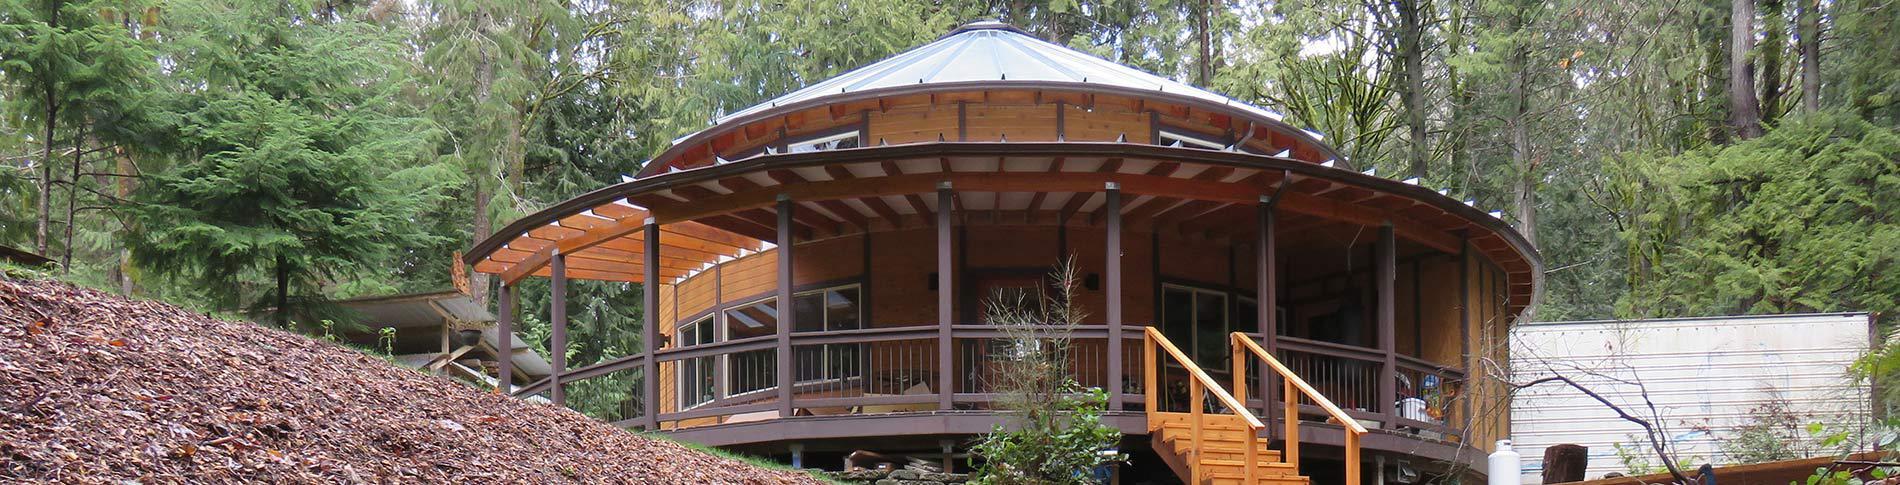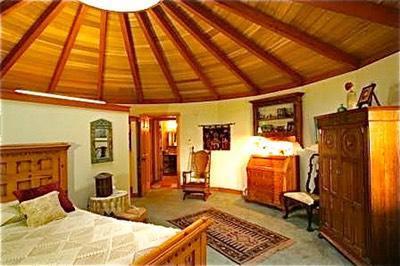The first image is the image on the left, the second image is the image on the right. Given the left and right images, does the statement "In the right image there is a staircase on the left leading up right towards the center." hold true? Answer yes or no. No. 